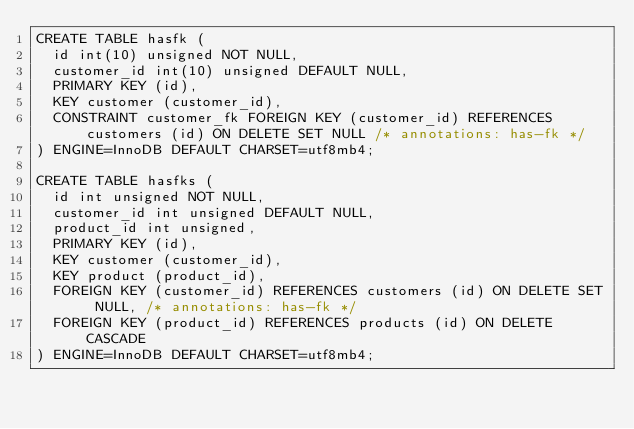<code> <loc_0><loc_0><loc_500><loc_500><_SQL_>CREATE TABLE hasfk (
  id int(10) unsigned NOT NULL,
  customer_id int(10) unsigned DEFAULT NULL,
  PRIMARY KEY (id),
  KEY customer (customer_id),
  CONSTRAINT customer_fk FOREIGN KEY (customer_id) REFERENCES customers (id) ON DELETE SET NULL /* annotations: has-fk */
) ENGINE=InnoDB DEFAULT CHARSET=utf8mb4;

CREATE TABLE hasfks (
  id int unsigned NOT NULL,
  customer_id int unsigned DEFAULT NULL,
  product_id int unsigned,
  PRIMARY KEY (id),
  KEY customer (customer_id),
  KEY product (product_id),
  FOREIGN KEY (customer_id) REFERENCES customers (id) ON DELETE SET NULL, /* annotations: has-fk */
  FOREIGN KEY (product_id) REFERENCES products (id) ON DELETE CASCADE
) ENGINE=InnoDB DEFAULT CHARSET=utf8mb4;
</code> 